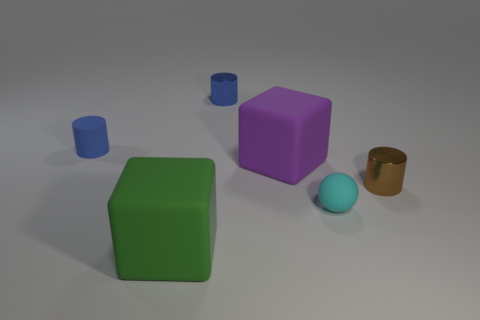What number of brown cylinders are on the right side of the small rubber object left of the blue metallic thing?
Keep it short and to the point. 1. What number of things are small cylinders that are to the left of the large green rubber block or matte blocks that are behind the tiny brown metal cylinder?
Give a very brief answer. 2. There is a green thing that is the same shape as the purple rubber thing; what is it made of?
Offer a terse response. Rubber. What number of things are matte objects to the left of the purple object or purple objects?
Offer a terse response. 3. There is a tiny blue object that is the same material as the large purple object; what is its shape?
Provide a short and direct response. Cylinder. What number of small yellow rubber objects are the same shape as the small blue matte thing?
Provide a short and direct response. 0. What material is the tiny cyan ball?
Ensure brevity in your answer.  Rubber. Does the matte cylinder have the same color as the shiny object that is left of the small brown thing?
Offer a very short reply. Yes. How many cylinders are either tiny blue rubber objects or small brown objects?
Provide a short and direct response. 2. The small rubber thing that is left of the cyan ball is what color?
Provide a succinct answer. Blue. 